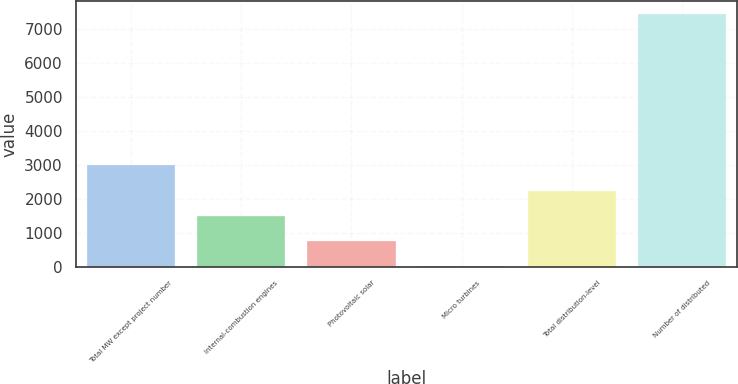Convert chart to OTSL. <chart><loc_0><loc_0><loc_500><loc_500><bar_chart><fcel>Total MW except project number<fcel>Internal-combustion engines<fcel>Photovoltaic solar<fcel>Micro turbines<fcel>Total distribution-level<fcel>Number of distributed<nl><fcel>2986.4<fcel>1498.2<fcel>754.1<fcel>10<fcel>2242.3<fcel>7451<nl></chart> 